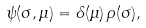Convert formula to latex. <formula><loc_0><loc_0><loc_500><loc_500>\psi ( \sigma , \mu ) = \delta ( \mu ) \, \rho ( \sigma ) ,</formula> 